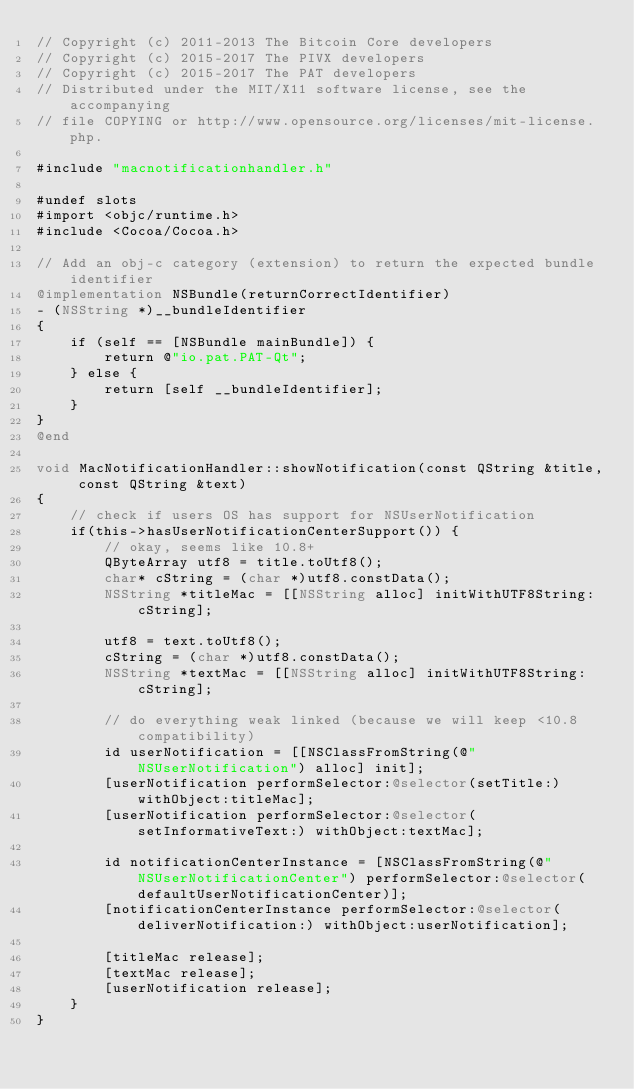<code> <loc_0><loc_0><loc_500><loc_500><_ObjectiveC_>// Copyright (c) 2011-2013 The Bitcoin Core developers
// Copyright (c) 2015-2017 The PIVX developers 
// Copyright (c) 2015-2017 The PAT developers
// Distributed under the MIT/X11 software license, see the accompanying
// file COPYING or http://www.opensource.org/licenses/mit-license.php.

#include "macnotificationhandler.h"

#undef slots
#import <objc/runtime.h>
#include <Cocoa/Cocoa.h>

// Add an obj-c category (extension) to return the expected bundle identifier
@implementation NSBundle(returnCorrectIdentifier)
- (NSString *)__bundleIdentifier
{
    if (self == [NSBundle mainBundle]) {
        return @"io.pat.PAT-Qt";
    } else {
        return [self __bundleIdentifier];
    }
}
@end

void MacNotificationHandler::showNotification(const QString &title, const QString &text)
{
    // check if users OS has support for NSUserNotification
    if(this->hasUserNotificationCenterSupport()) {
        // okay, seems like 10.8+
        QByteArray utf8 = title.toUtf8();
        char* cString = (char *)utf8.constData();
        NSString *titleMac = [[NSString alloc] initWithUTF8String:cString];

        utf8 = text.toUtf8();
        cString = (char *)utf8.constData();
        NSString *textMac = [[NSString alloc] initWithUTF8String:cString];

        // do everything weak linked (because we will keep <10.8 compatibility)
        id userNotification = [[NSClassFromString(@"NSUserNotification") alloc] init];
        [userNotification performSelector:@selector(setTitle:) withObject:titleMac];
        [userNotification performSelector:@selector(setInformativeText:) withObject:textMac];

        id notificationCenterInstance = [NSClassFromString(@"NSUserNotificationCenter") performSelector:@selector(defaultUserNotificationCenter)];
        [notificationCenterInstance performSelector:@selector(deliverNotification:) withObject:userNotification];

        [titleMac release];
        [textMac release];
        [userNotification release];
    }
}
</code> 